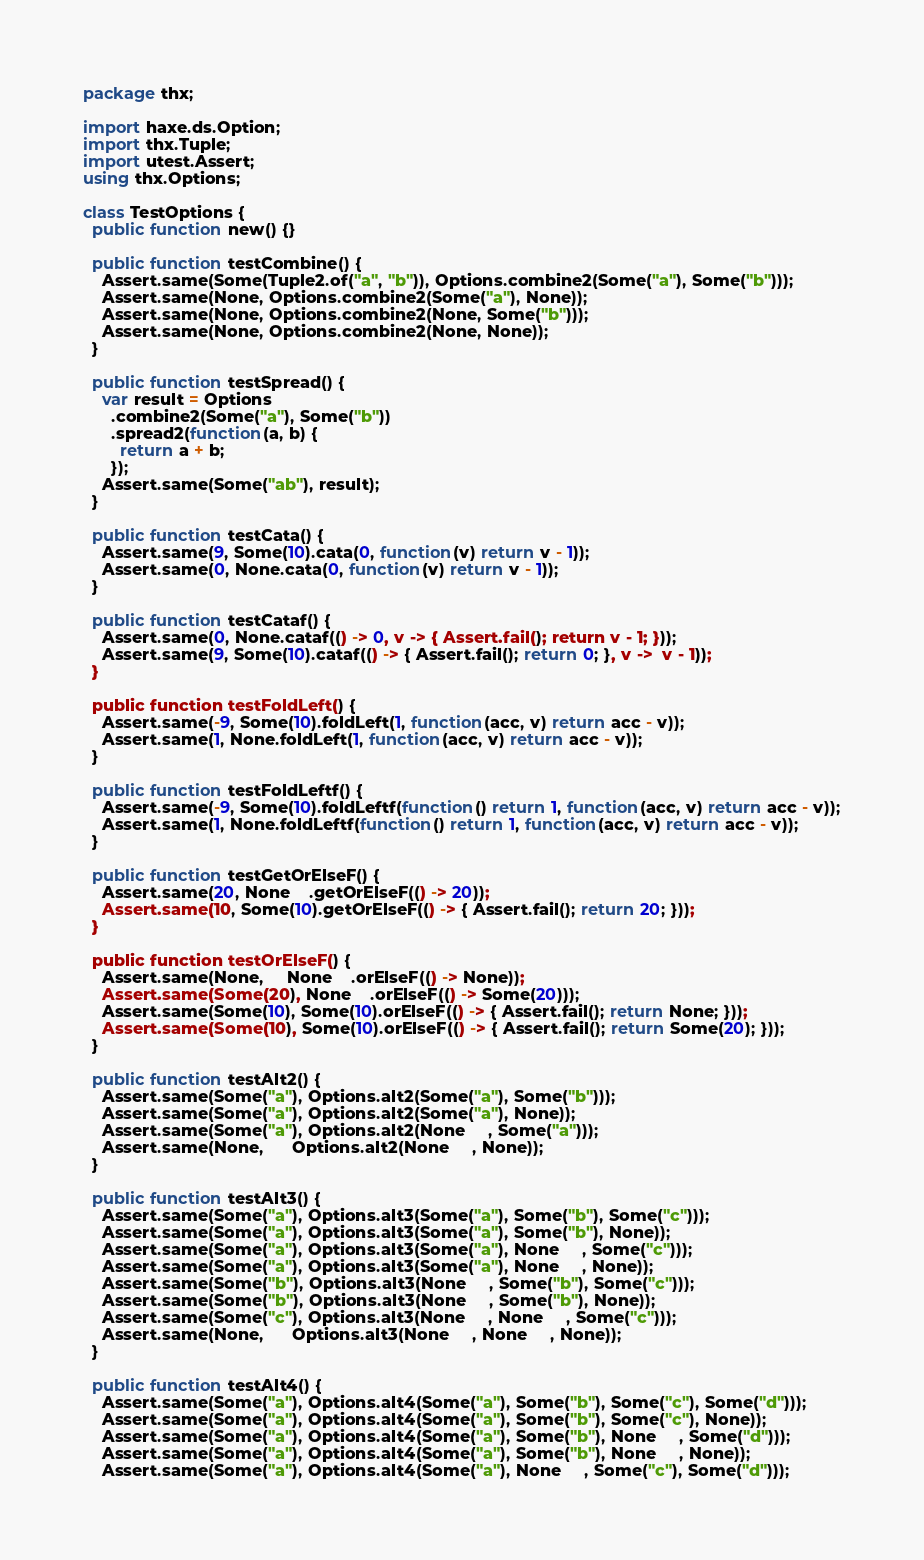Convert code to text. <code><loc_0><loc_0><loc_500><loc_500><_Haxe_>package thx;

import haxe.ds.Option;
import thx.Tuple;
import utest.Assert;
using thx.Options;

class TestOptions {
  public function new() {}

  public function testCombine() {
    Assert.same(Some(Tuple2.of("a", "b")), Options.combine2(Some("a"), Some("b")));
    Assert.same(None, Options.combine2(Some("a"), None));
    Assert.same(None, Options.combine2(None, Some("b")));
    Assert.same(None, Options.combine2(None, None));
  }

  public function testSpread() {
    var result = Options
      .combine2(Some("a"), Some("b"))
      .spread2(function(a, b) {
        return a + b;
      });
    Assert.same(Some("ab"), result);
  }

  public function testCata() {
    Assert.same(9, Some(10).cata(0, function(v) return v - 1));
    Assert.same(0, None.cata(0, function(v) return v - 1));
  }

  public function testCataf() {
    Assert.same(0, None.cataf(() -> 0, v -> { Assert.fail(); return v - 1; }));
    Assert.same(9, Some(10).cataf(() -> { Assert.fail(); return 0; }, v ->  v - 1));
  }

  public function testFoldLeft() {
    Assert.same(-9, Some(10).foldLeft(1, function(acc, v) return acc - v));
    Assert.same(1, None.foldLeft(1, function(acc, v) return acc - v));
  }

  public function testFoldLeftf() {
    Assert.same(-9, Some(10).foldLeftf(function() return 1, function(acc, v) return acc - v));
    Assert.same(1, None.foldLeftf(function() return 1, function(acc, v) return acc - v));
  }

  public function testGetOrElseF() {
    Assert.same(20, None    .getOrElseF(() -> 20));
    Assert.same(10, Some(10).getOrElseF(() -> { Assert.fail(); return 20; }));
  }

  public function testOrElseF() {
    Assert.same(None,     None    .orElseF(() -> None));
    Assert.same(Some(20), None    .orElseF(() -> Some(20)));
    Assert.same(Some(10), Some(10).orElseF(() -> { Assert.fail(); return None; }));
    Assert.same(Some(10), Some(10).orElseF(() -> { Assert.fail(); return Some(20); }));
  }

  public function testAlt2() {
    Assert.same(Some("a"), Options.alt2(Some("a"), Some("b")));
    Assert.same(Some("a"), Options.alt2(Some("a"), None));
    Assert.same(Some("a"), Options.alt2(None     , Some("a")));
    Assert.same(None,      Options.alt2(None     , None));
  }

  public function testAlt3() {
    Assert.same(Some("a"), Options.alt3(Some("a"), Some("b"), Some("c")));
    Assert.same(Some("a"), Options.alt3(Some("a"), Some("b"), None));
    Assert.same(Some("a"), Options.alt3(Some("a"), None     , Some("c")));
    Assert.same(Some("a"), Options.alt3(Some("a"), None     , None));
    Assert.same(Some("b"), Options.alt3(None     , Some("b"), Some("c")));
    Assert.same(Some("b"), Options.alt3(None     , Some("b"), None));
    Assert.same(Some("c"), Options.alt3(None     , None     , Some("c")));
    Assert.same(None,      Options.alt3(None     , None     , None));
  }

  public function testAlt4() {
    Assert.same(Some("a"), Options.alt4(Some("a"), Some("b"), Some("c"), Some("d")));
    Assert.same(Some("a"), Options.alt4(Some("a"), Some("b"), Some("c"), None));
    Assert.same(Some("a"), Options.alt4(Some("a"), Some("b"), None     , Some("d")));
    Assert.same(Some("a"), Options.alt4(Some("a"), Some("b"), None     , None));
    Assert.same(Some("a"), Options.alt4(Some("a"), None     , Some("c"), Some("d")));</code> 